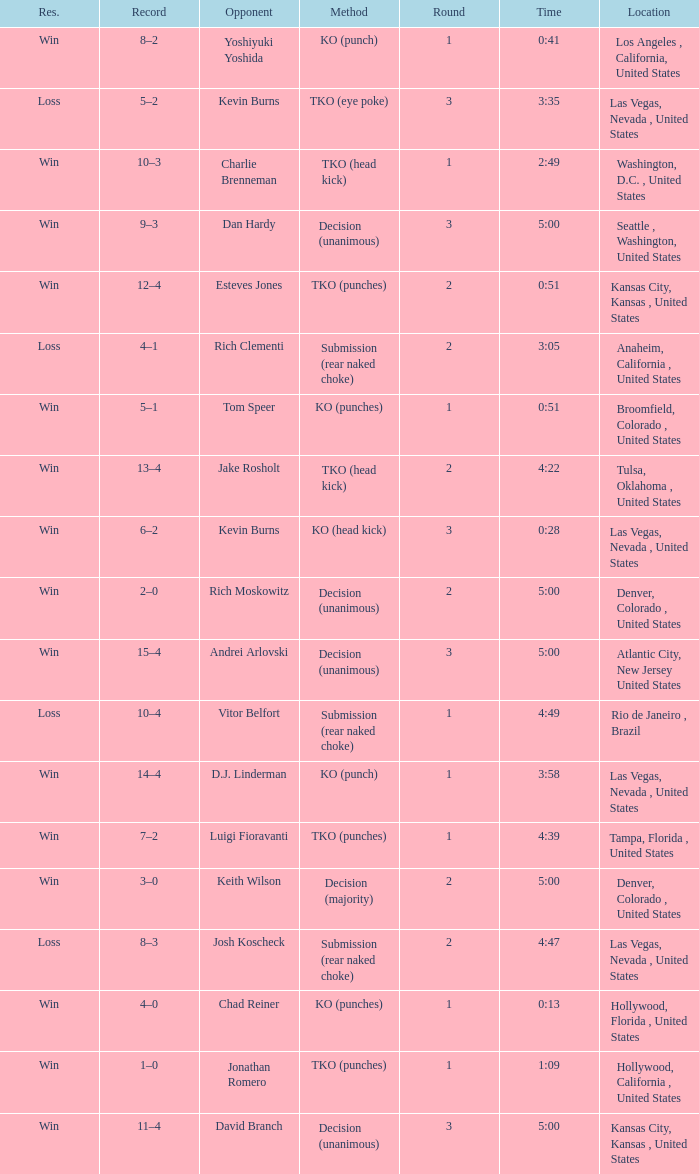What is the result for rounds under 2 against D.J. Linderman? Win. 